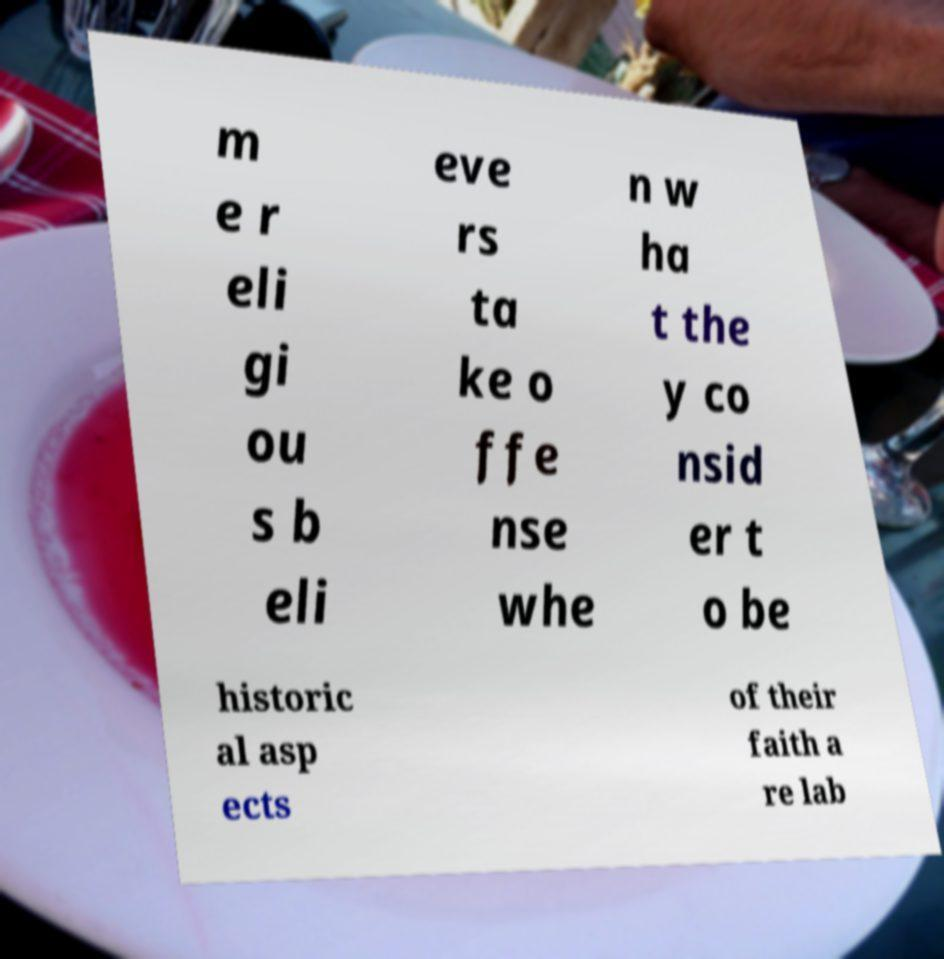I need the written content from this picture converted into text. Can you do that? m e r eli gi ou s b eli eve rs ta ke o ffe nse whe n w ha t the y co nsid er t o be historic al asp ects of their faith a re lab 